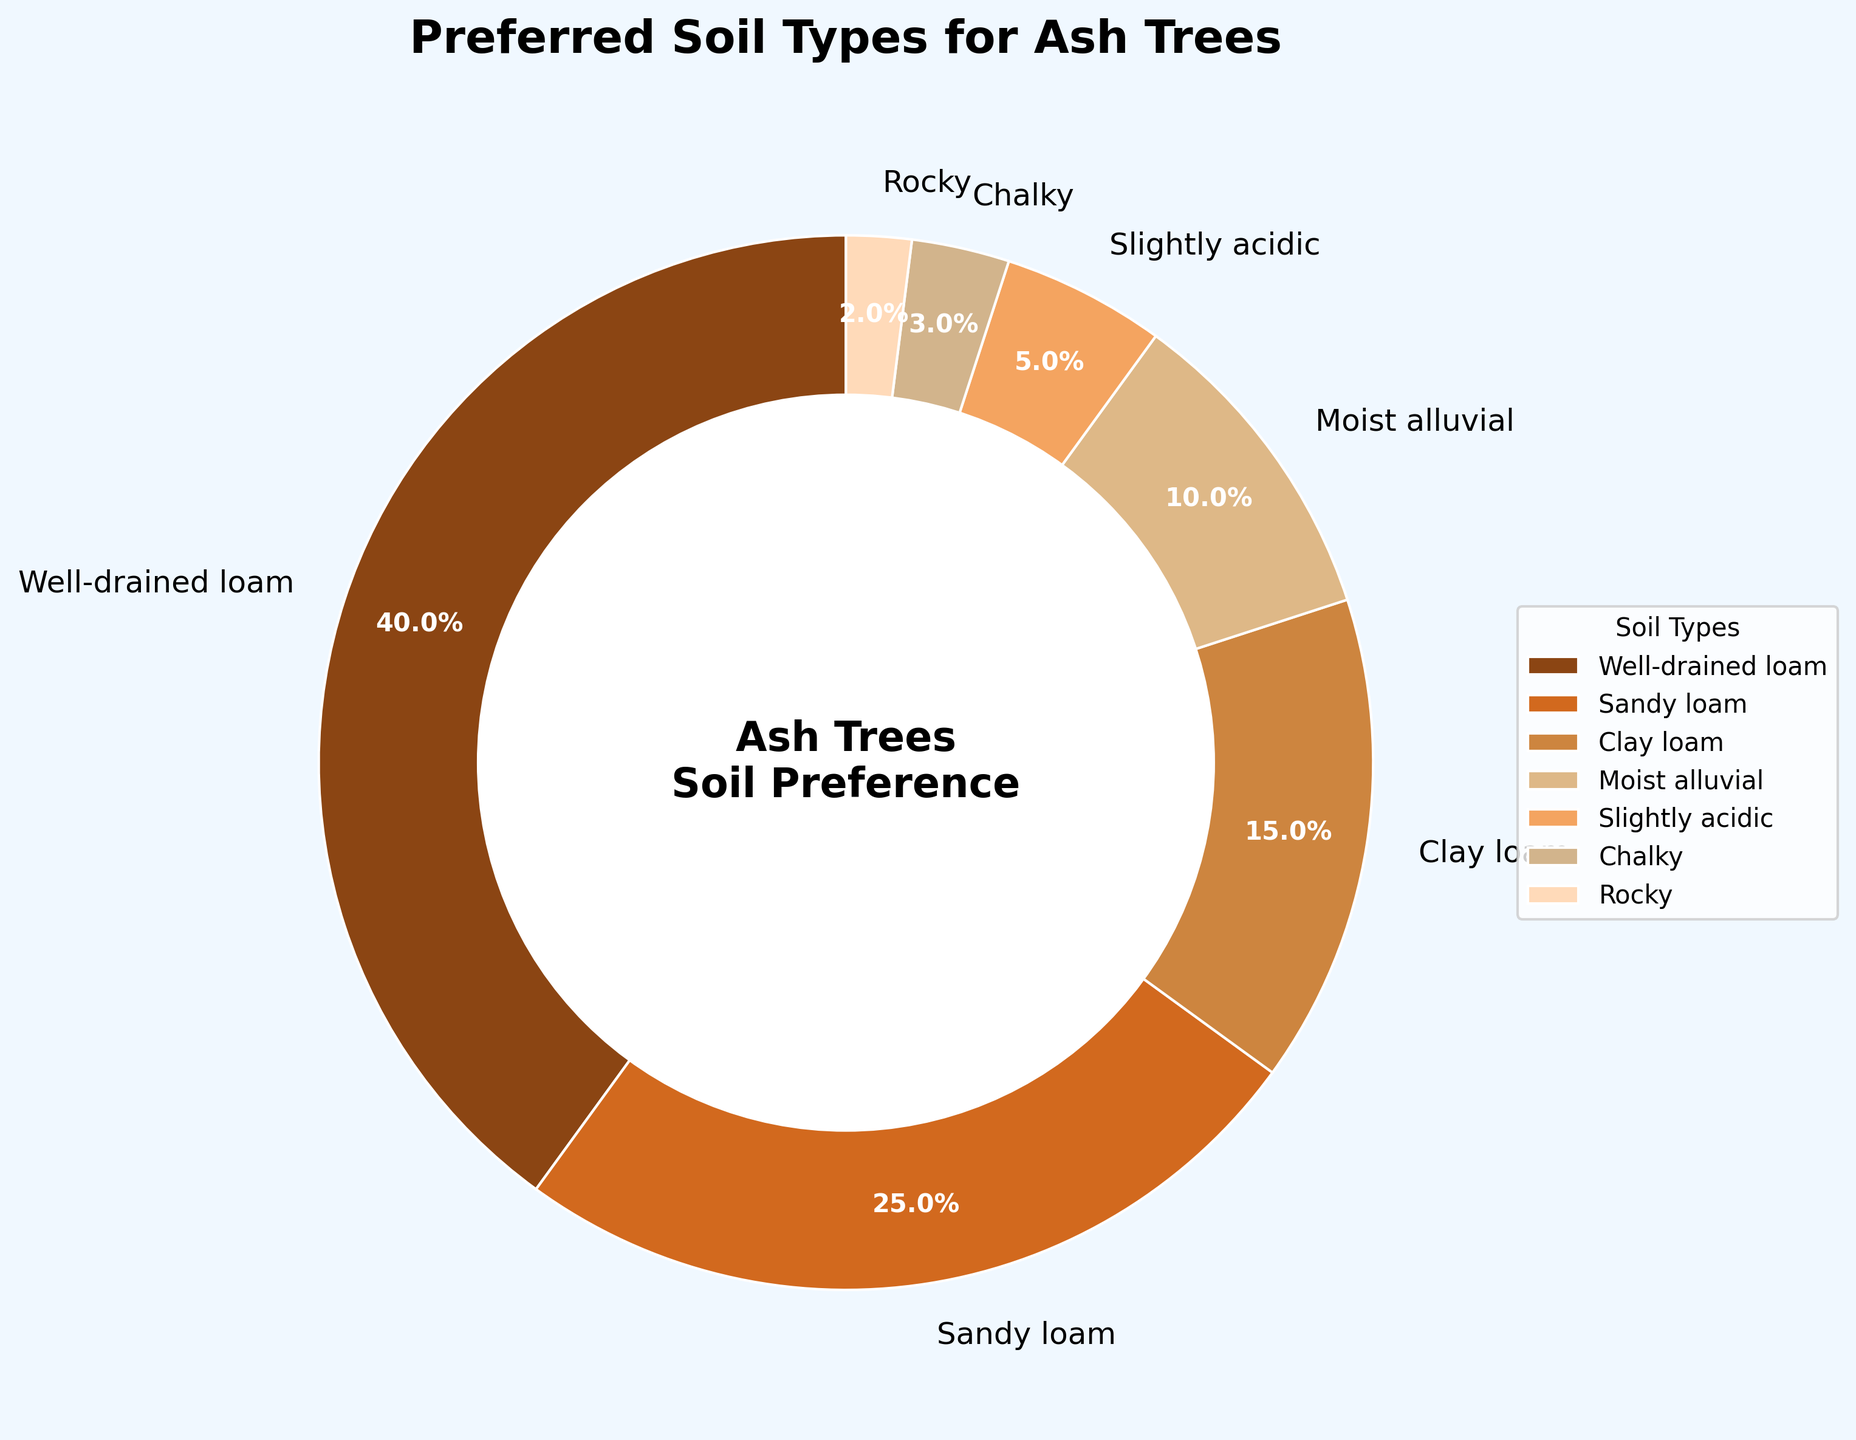What is the most preferred soil type for ash trees? By referring to the size of the sections in the pie chart, we see that "Well-drained loam" occupies the largest portion at 40%.
Answer: Well-drained loam Which soil type is least preferred by ash trees? The smallest section in the pie chart is labeled "Rocky," which occupies 2% of the chart.
Answer: Rocky What is the combined percentage of Well-drained loam and Sandy loam? Adding the percentages for "Well-drained loam" (40%) and "Sandy loam" (25%) gives a total of 65%.
Answer: 65% How does the percentage of Chalky soil compare to Slightly acidic soil? The pie chart shows that "Chalky" soil is represented by 3%, while "Slightly acidic" soil is represented by 5%. Therefore, Chalky soil has a lower percentage than Slightly acidic soil.
Answer: Chalky soil is less preferred than Slightly acidic soil Which two soil types together make up exactly 25% of the preferred soil types? By checking the pie chart, "Clay loam" is 15% and "Moist alluvial" is 10%. Adding these two percentages results in 25%.
Answer: Clay loam and Moist alluvial What is the total percentage for soil types that have less than 10% share each? The specific soil types with less than 10% are "Slightly acidic" (5%), "Chalky" (3%), and "Rocky" (2%). Adding these together gives 5% + 3% + 2% = 10%.
Answer: 10% By how much does the preference for Well-drained loam exceed the preference for Moist alluvial soil? Well-drained loam has a 40% share, and Moist alluvial soil has a 10% share. The difference between them is 40% - 10% = 30%.
Answer: 30% Which soil types fall within the range of 10% to 20% preference? According to the pie chart, "Clay loam" is the only soil type within the 10%-20% range, with a 15% share.
Answer: Clay loam What visual feature is used to differentiate the segments in the pie chart? The pie chart uses different colors for each segment to visually distinguish between the various soil types. Additionally, each segment is labeled with both the soil type and its percentage.
Answer: Different colors and labels 